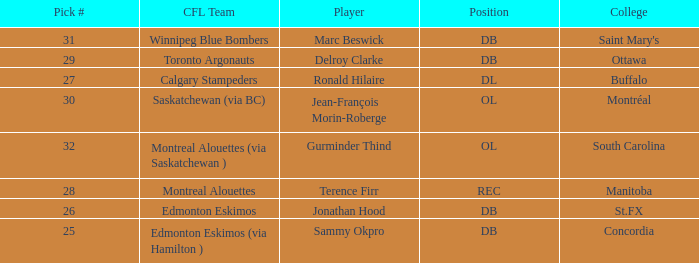What is buffalo's pick #? 27.0. 